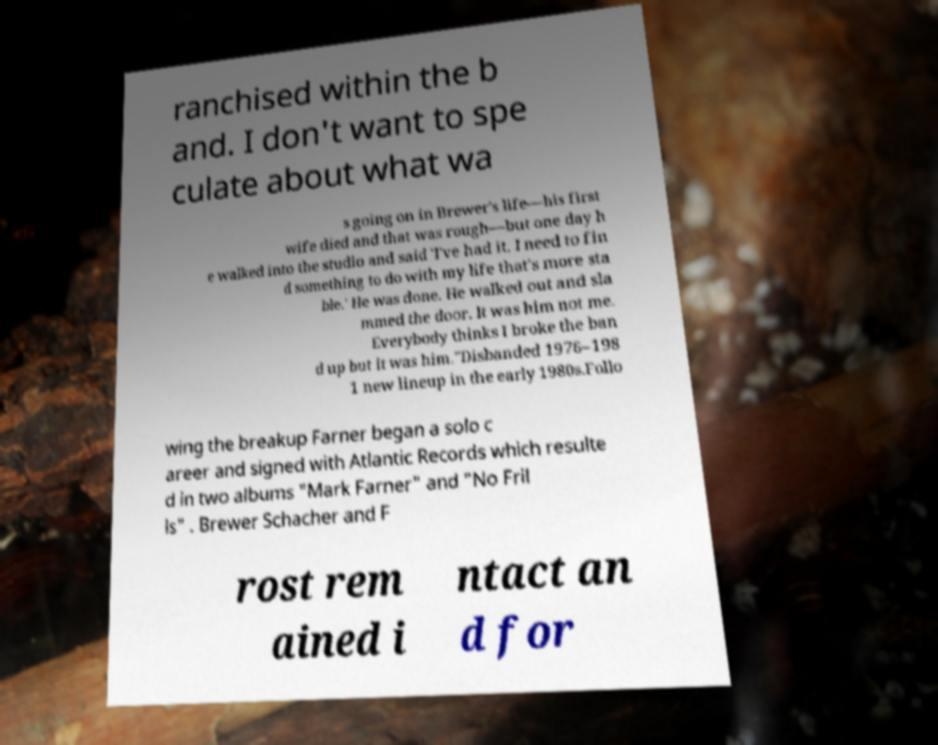Please identify and transcribe the text found in this image. ranchised within the b and. I don't want to spe culate about what wa s going on in Brewer's life—his first wife died and that was rough—but one day h e walked into the studio and said 'I've had it. I need to fin d something to do with my life that's more sta ble.' He was done. He walked out and sla mmed the door. It was him not me. Everybody thinks I broke the ban d up but it was him."Disbanded 1976–198 1 new lineup in the early 1980s.Follo wing the breakup Farner began a solo c areer and signed with Atlantic Records which resulte d in two albums "Mark Farner" and "No Fril ls" . Brewer Schacher and F rost rem ained i ntact an d for 